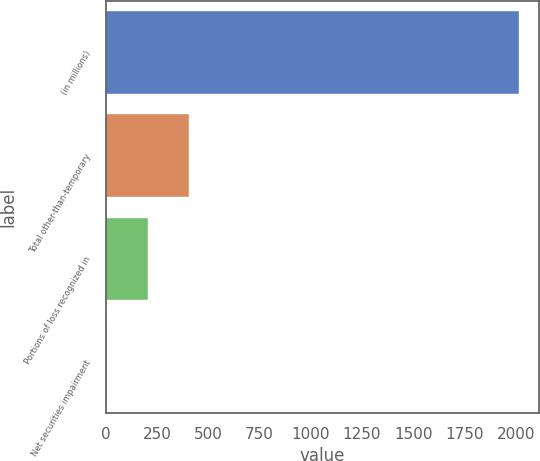Convert chart. <chart><loc_0><loc_0><loc_500><loc_500><bar_chart><fcel>(in millions)<fcel>Total other-than-temporary<fcel>Portions of loss recognized in<fcel>Net securities impairment<nl><fcel>2015<fcel>408.6<fcel>207.8<fcel>7<nl></chart> 